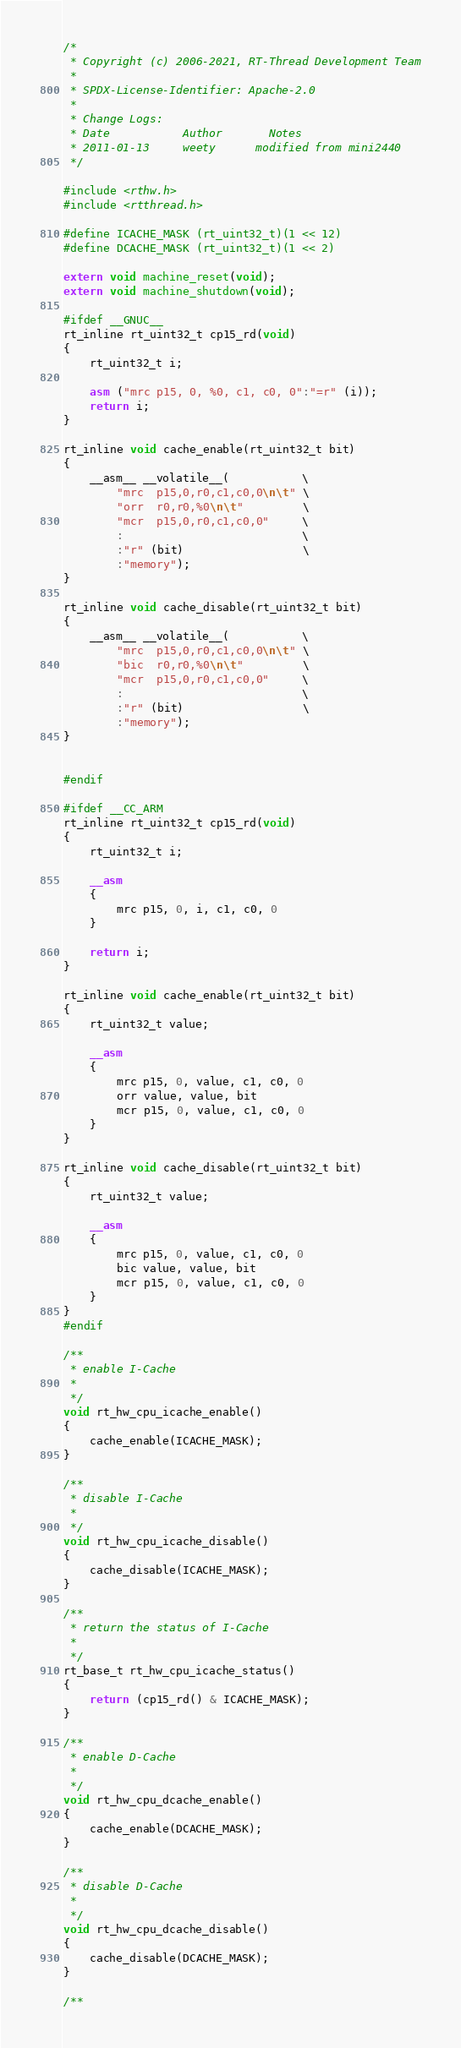<code> <loc_0><loc_0><loc_500><loc_500><_C_>/*
 * Copyright (c) 2006-2021, RT-Thread Development Team
 *
 * SPDX-License-Identifier: Apache-2.0
 *
 * Change Logs:
 * Date           Author       Notes
 * 2011-01-13     weety      modified from mini2440
 */

#include <rthw.h>
#include <rtthread.h>

#define ICACHE_MASK (rt_uint32_t)(1 << 12)
#define DCACHE_MASK (rt_uint32_t)(1 << 2)

extern void machine_reset(void);
extern void machine_shutdown(void);

#ifdef __GNUC__
rt_inline rt_uint32_t cp15_rd(void)
{
    rt_uint32_t i;

    asm ("mrc p15, 0, %0, c1, c0, 0":"=r" (i));
    return i;
}

rt_inline void cache_enable(rt_uint32_t bit)
{
    __asm__ __volatile__(           \
        "mrc  p15,0,r0,c1,c0,0\n\t" \
        "orr  r0,r0,%0\n\t"         \
        "mcr  p15,0,r0,c1,c0,0"     \
        :                           \
        :"r" (bit)                  \
        :"memory");
}

rt_inline void cache_disable(rt_uint32_t bit)
{
    __asm__ __volatile__(           \
        "mrc  p15,0,r0,c1,c0,0\n\t" \
        "bic  r0,r0,%0\n\t"         \
        "mcr  p15,0,r0,c1,c0,0"     \
        :                           \
        :"r" (bit)                  \
        :"memory");
}


#endif

#ifdef __CC_ARM
rt_inline rt_uint32_t cp15_rd(void)
{
    rt_uint32_t i;

    __asm
    {
        mrc p15, 0, i, c1, c0, 0
    }

    return i;
}

rt_inline void cache_enable(rt_uint32_t bit)
{
    rt_uint32_t value;

    __asm
    {
        mrc p15, 0, value, c1, c0, 0
        orr value, value, bit
        mcr p15, 0, value, c1, c0, 0
    }
}

rt_inline void cache_disable(rt_uint32_t bit)
{
    rt_uint32_t value;

    __asm
    {
        mrc p15, 0, value, c1, c0, 0
        bic value, value, bit
        mcr p15, 0, value, c1, c0, 0
    }
}
#endif

/**
 * enable I-Cache
 *
 */
void rt_hw_cpu_icache_enable()
{
    cache_enable(ICACHE_MASK);
}

/**
 * disable I-Cache
 *
 */
void rt_hw_cpu_icache_disable()
{
    cache_disable(ICACHE_MASK);
}

/**
 * return the status of I-Cache
 *
 */
rt_base_t rt_hw_cpu_icache_status()
{
    return (cp15_rd() & ICACHE_MASK);
}

/**
 * enable D-Cache
 *
 */
void rt_hw_cpu_dcache_enable()
{
    cache_enable(DCACHE_MASK);
}

/**
 * disable D-Cache
 *
 */
void rt_hw_cpu_dcache_disable()
{
    cache_disable(DCACHE_MASK);
}

/**</code> 